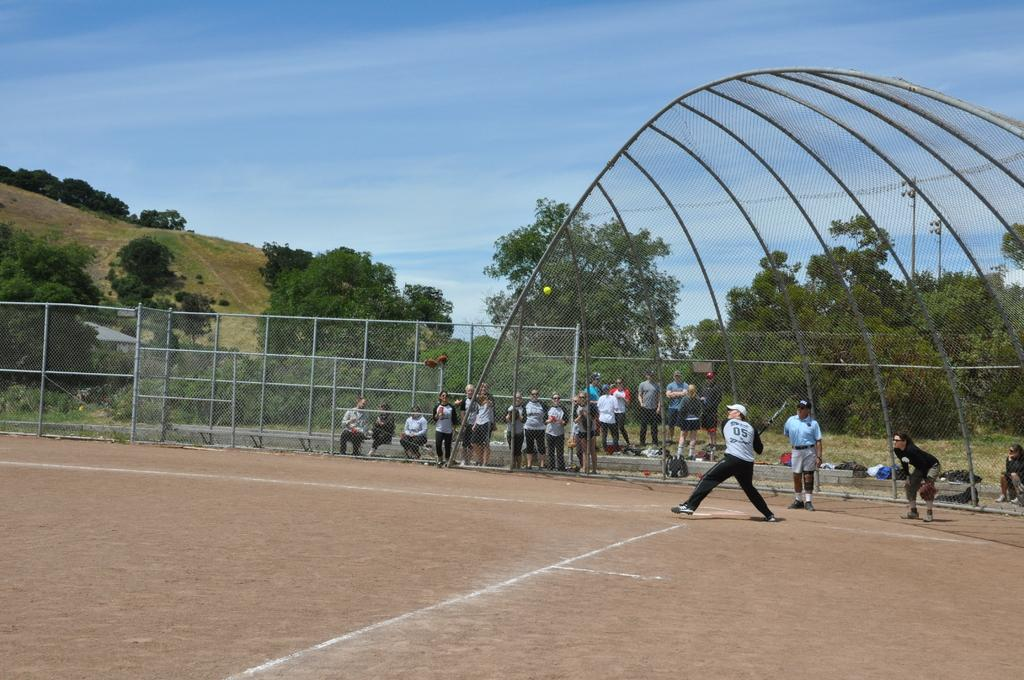<image>
Give a short and clear explanation of the subsequent image. A batter wearing a number 05 uniform gets ready to take a swing at a pitch. 